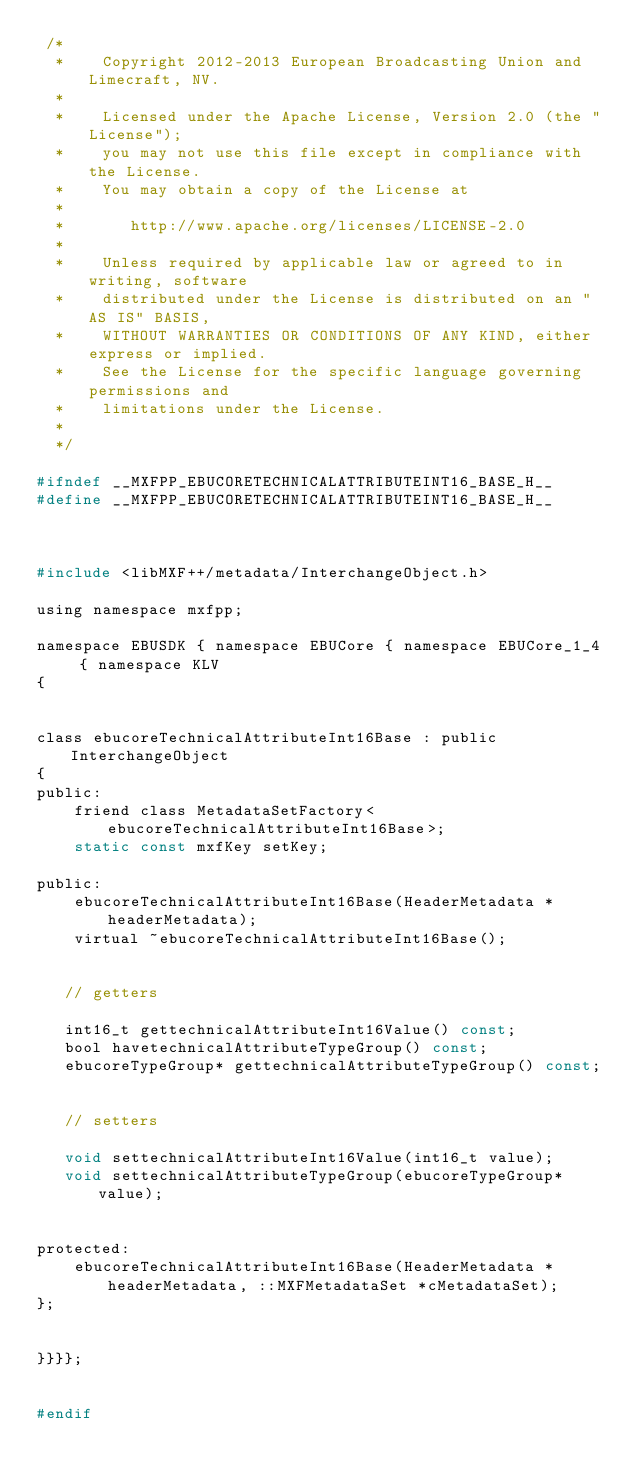<code> <loc_0><loc_0><loc_500><loc_500><_C_> /*
  *    Copyright 2012-2013 European Broadcasting Union and Limecraft, NV.
  *
  *    Licensed under the Apache License, Version 2.0 (the "License");
  *    you may not use this file except in compliance with the License.
  *    You may obtain a copy of the License at
  *
  *       http://www.apache.org/licenses/LICENSE-2.0
  *
  *    Unless required by applicable law or agreed to in writing, software
  *    distributed under the License is distributed on an "AS IS" BASIS,
  *    WITHOUT WARRANTIES OR CONDITIONS OF ANY KIND, either express or implied.
  *    See the License for the specific language governing permissions and
  *    limitations under the License.
  *
  */
  
#ifndef __MXFPP_EBUCORETECHNICALATTRIBUTEINT16_BASE_H__
#define __MXFPP_EBUCORETECHNICALATTRIBUTEINT16_BASE_H__



#include <libMXF++/metadata/InterchangeObject.h>

using namespace mxfpp;

namespace EBUSDK { namespace EBUCore { namespace EBUCore_1_4 { namespace KLV
{


class ebucoreTechnicalAttributeInt16Base : public InterchangeObject
{
public:
    friend class MetadataSetFactory<ebucoreTechnicalAttributeInt16Base>;
    static const mxfKey setKey;

public:
    ebucoreTechnicalAttributeInt16Base(HeaderMetadata *headerMetadata);
    virtual ~ebucoreTechnicalAttributeInt16Base();


   // getters

   int16_t gettechnicalAttributeInt16Value() const;
   bool havetechnicalAttributeTypeGroup() const;
   ebucoreTypeGroup* gettechnicalAttributeTypeGroup() const;


   // setters

   void settechnicalAttributeInt16Value(int16_t value);
   void settechnicalAttributeTypeGroup(ebucoreTypeGroup* value);


protected:
    ebucoreTechnicalAttributeInt16Base(HeaderMetadata *headerMetadata, ::MXFMetadataSet *cMetadataSet);
};


}}}};


#endif
</code> 